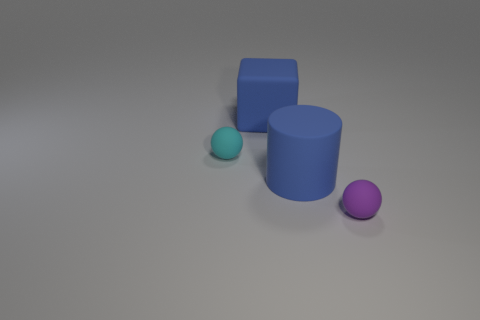Add 3 small spheres. How many objects exist? 7 Subtract all cylinders. How many objects are left? 3 Add 3 large matte things. How many large matte things exist? 5 Subtract 0 cyan cylinders. How many objects are left? 4 Subtract all big blue matte things. Subtract all big purple balls. How many objects are left? 2 Add 1 purple things. How many purple things are left? 2 